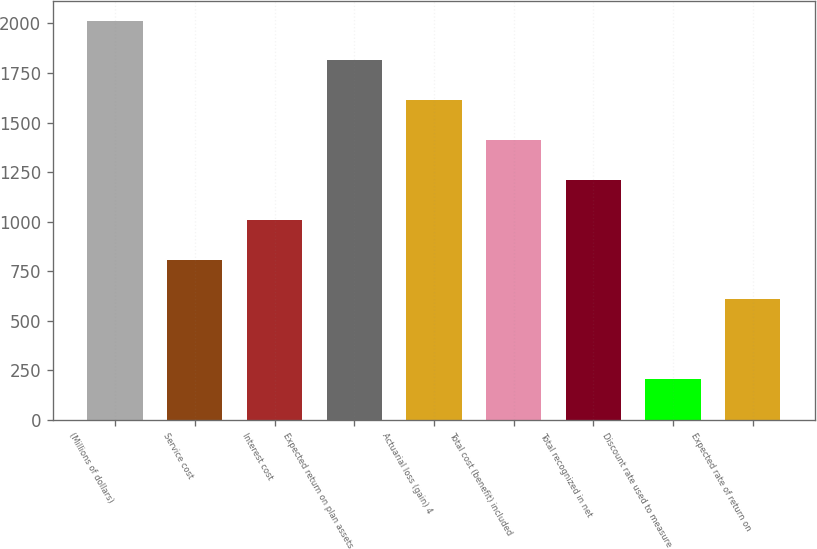Convert chart to OTSL. <chart><loc_0><loc_0><loc_500><loc_500><bar_chart><fcel>(Millions of dollars)<fcel>Service cost<fcel>Interest cost<fcel>Expected return on plan assets<fcel>Actuarial loss (gain) 4<fcel>Total cost (benefit) included<fcel>Total recognized in net<fcel>Discount rate used to measure<fcel>Expected rate of return on<nl><fcel>2015<fcel>808.28<fcel>1009.4<fcel>1813.88<fcel>1612.76<fcel>1411.64<fcel>1210.52<fcel>204.92<fcel>607.16<nl></chart> 